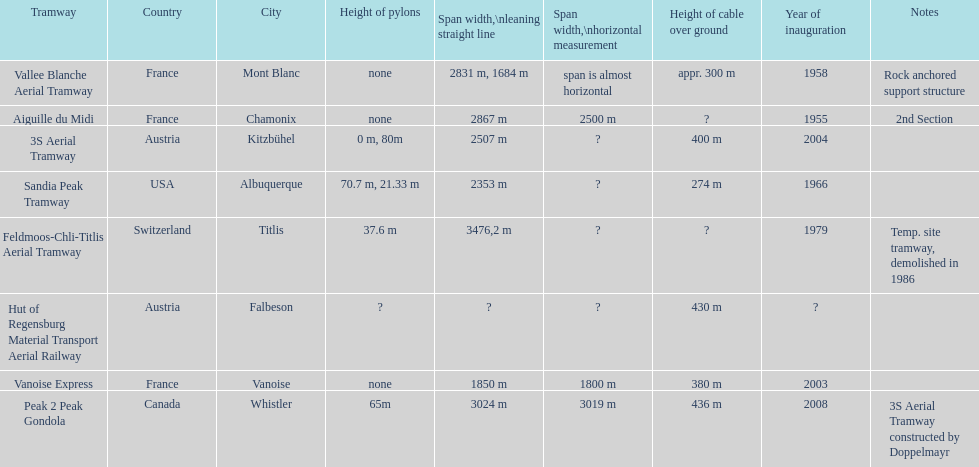Was the sandia peak tramway innagurate before or after the 3s aerial tramway? Before. 